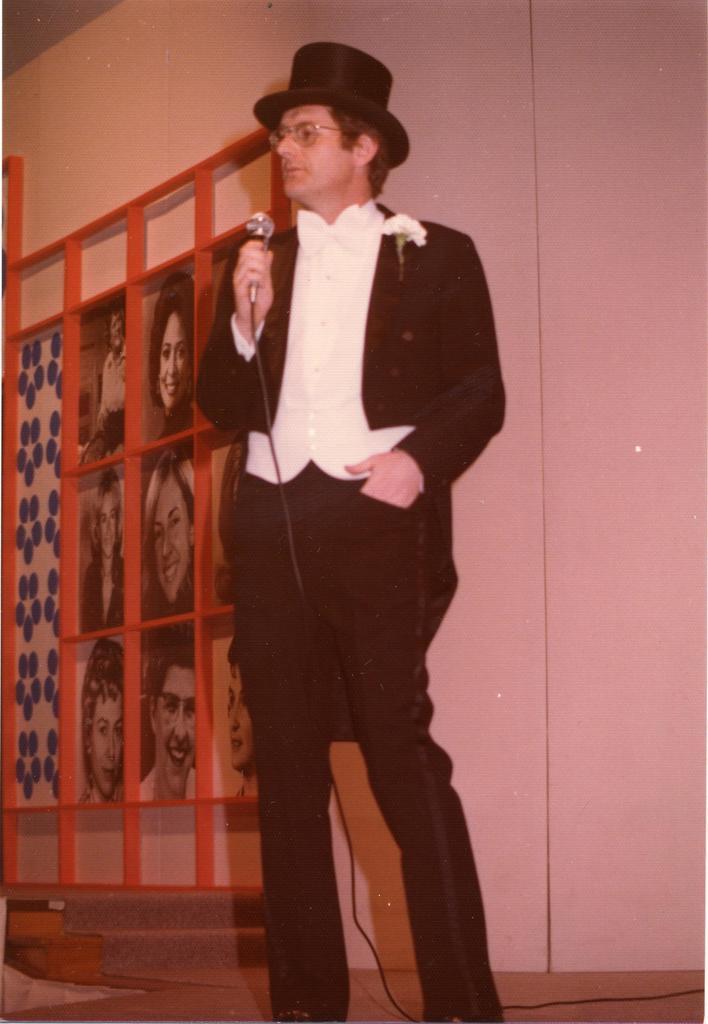Could you give a brief overview of what you see in this image? In this image I can see a person standing and holding a microphone and the person is wearing black and white dress, background I can see few photos and the wall is in white color. 